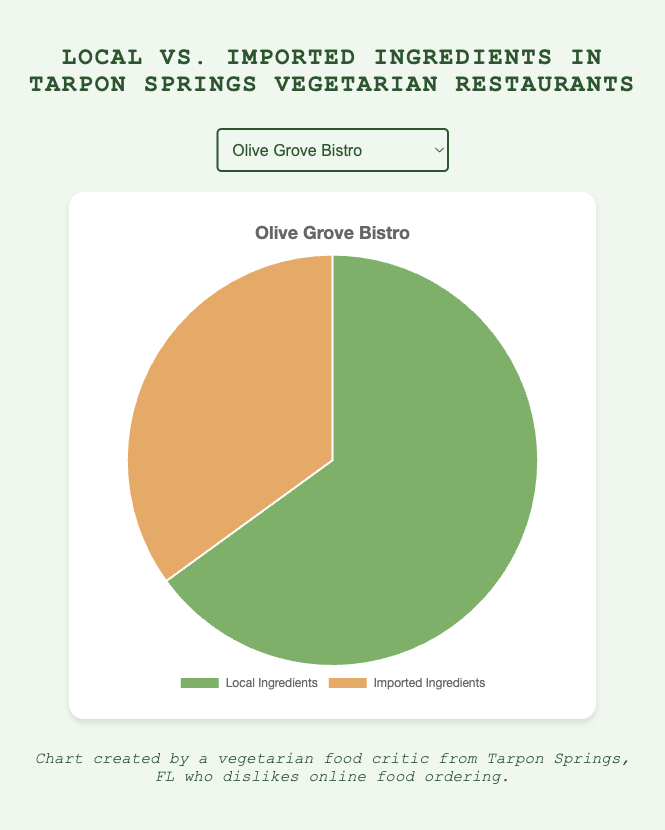Which restaurant uses the highest percentage of local ingredients? Identify the restaurant with the highest percentage value for local ingredients. Zorba's Vegetarian Delight has 80%, which is the highest.
Answer: Zorba's Vegetarian Delight In which restaurant is the percentage of imported ingredients closest to 30%? Identify the restaurant with a percentage closest to 30% for imported ingredients. Hippocrates' Garden has 30% imported ingredients, which is exactly 30%.
Answer: Hippocrates' Garden Does Green Harmony use more local or imported ingredients? Compare the percentages of local and imported ingredients for Green Harmony. It uses 75% local and 25% imported ingredients, so it uses more local ingredients.
Answer: More local ingredients What is the difference between the highest and lowest percentage of local ingredients used? Identify the highest (80% by Zorba's Vegetarian Delight) and lowest (60% by Sunshine Veggie Café) percentages of local ingredients, then calculate the difference: 80% - 60% = 20%.
Answer: 20% How many restaurants use more than 70% local ingredients? Count the restaurants with local ingredients percentages greater than 70%: Green Harmony (75%), Hippocrates' Garden (70%), and Zorba's Vegetarian Delight (80%). There are three such restaurants in total.
Answer: 3 For which restaurant is the percentage difference between local and imported ingredients the smallest? Calculate the difference for each restaurant:
- Olive Grove Bistro: 65% - 35% = 30%
- Green Harmony: 75% - 25% = 50%
- Hippocrates' Garden: 70% - 30% = 40%
- Sunshine Veggie Café: 60% - 40% = 20%
- Zorba's Vegetarian Delight: 80% - 20% = 60%
The smallest difference (20%) is for Sunshine Veggie Café.
Answer: Sunshine Veggie Café Which restaurant has a local to imported ingredients ratio of 2:1? Calculate the ratios for each restaurant:
- Olive Grove Bistro: 65/35 = 1.857 (not 2:1)
- Green Harmony: 75/25 = 3 (not 2:1)
- Hippocrates' Garden: 70/30 = 2.333 (not 2:1)
- Sunshine Veggie Café: 60/40 = 1.5 (not 2:1)
- Zorba's Vegetarian Delight: 80/20 = 4 (not 2:1)
None of the restaurants have a ratio of exactly 2:1.
Answer: None Which restaurant uses the lowest percentage of imported ingredients? Identify the restaurant with the lowest percentage value for imported ingredients. Zorba's Vegetarian Delight has 20%, which is the lowest.
Answer: Zorba's Vegetarian Delight What is the average percentage of imported ingredients used across all restaurants? Sum the percentages of imported ingredients (35% + 25% + 30% + 40% + 20%) and divide by the number of restaurants (5). Calculation: (35 + 25 + 30 + 40 + 20) / 5 = 30%.
Answer: 30% If you combine Olive Grove Bistro and Sunshine Veggie Café, what is the combined percentage of local ingredients? Sum the local percentages for Olive Grove Bistro (65%) and Sunshine Veggie Café (60%) and then calculate the average: (65 + 60) / 2 = 62.5%.
Answer: 62.5% 